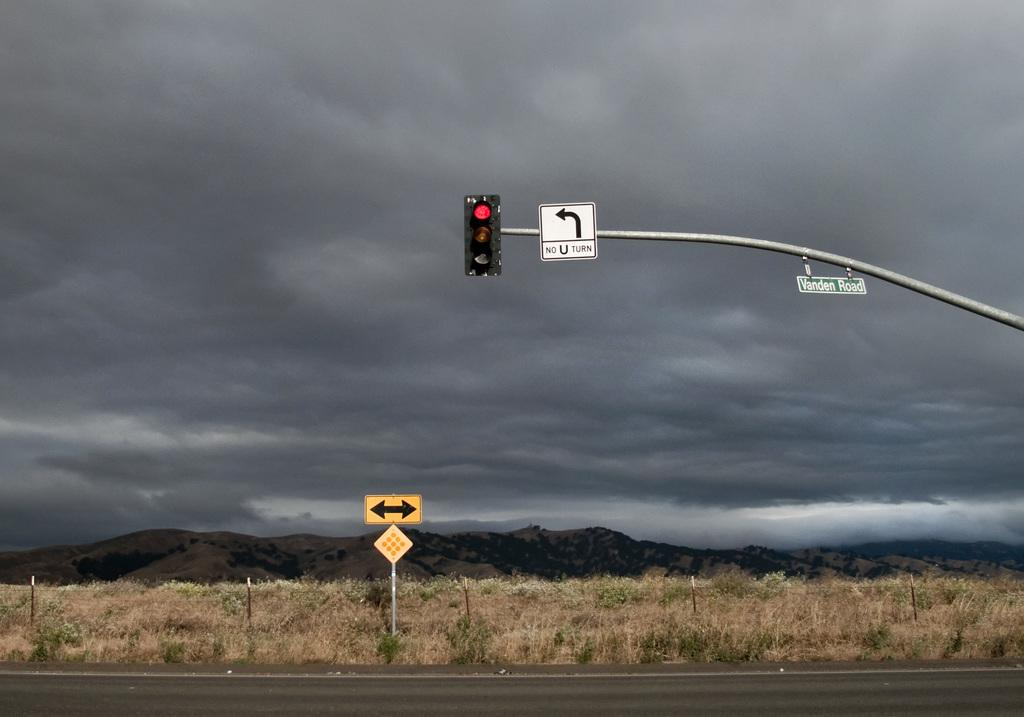Provide a one-sentence caption for the provided image. dark cloudy day at an intersection and a red light and a no u turn sign. 